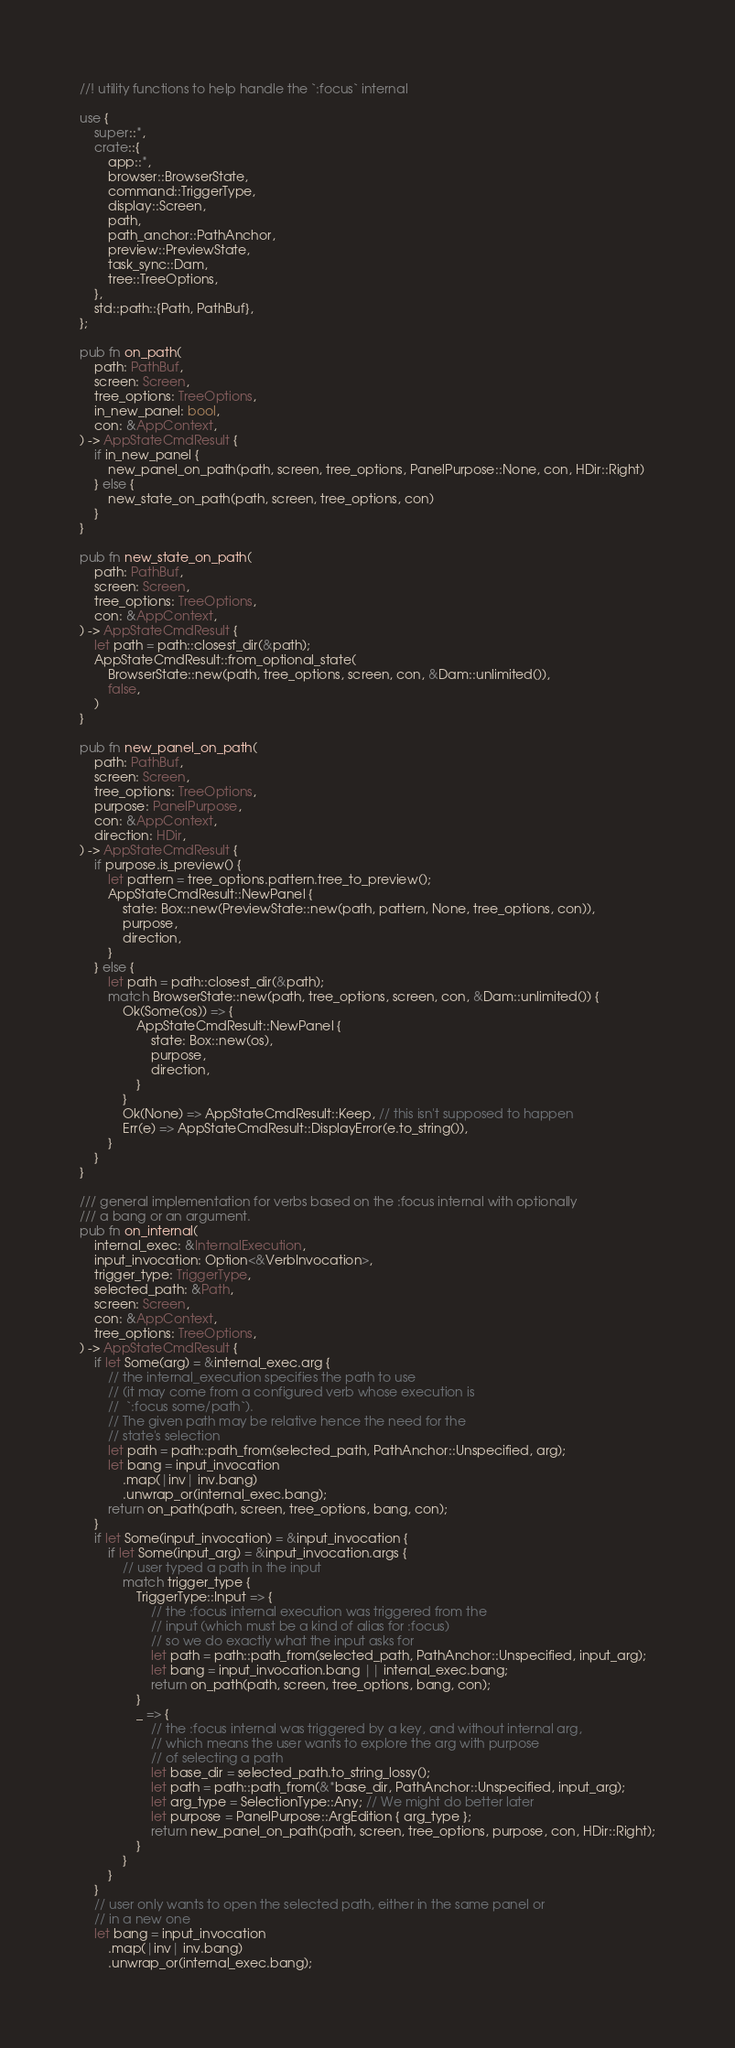Convert code to text. <code><loc_0><loc_0><loc_500><loc_500><_Rust_>//! utility functions to help handle the `:focus` internal

use {
    super::*,
    crate::{
        app::*,
        browser::BrowserState,
        command::TriggerType,
        display::Screen,
        path,
        path_anchor::PathAnchor,
        preview::PreviewState,
        task_sync::Dam,
        tree::TreeOptions,
    },
    std::path::{Path, PathBuf},
};

pub fn on_path(
    path: PathBuf,
    screen: Screen,
    tree_options: TreeOptions,
    in_new_panel: bool,
    con: &AppContext,
) -> AppStateCmdResult {
    if in_new_panel {
        new_panel_on_path(path, screen, tree_options, PanelPurpose::None, con, HDir::Right)
    } else {
        new_state_on_path(path, screen, tree_options, con)
    }
}

pub fn new_state_on_path(
    path: PathBuf,
    screen: Screen,
    tree_options: TreeOptions,
    con: &AppContext,
) -> AppStateCmdResult {
    let path = path::closest_dir(&path);
    AppStateCmdResult::from_optional_state(
        BrowserState::new(path, tree_options, screen, con, &Dam::unlimited()),
        false,
    )
}

pub fn new_panel_on_path(
    path: PathBuf,
    screen: Screen,
    tree_options: TreeOptions,
    purpose: PanelPurpose,
    con: &AppContext,
    direction: HDir,
) -> AppStateCmdResult {
    if purpose.is_preview() {
        let pattern = tree_options.pattern.tree_to_preview();
        AppStateCmdResult::NewPanel {
            state: Box::new(PreviewState::new(path, pattern, None, tree_options, con)),
            purpose,
            direction,
        }
    } else {
        let path = path::closest_dir(&path);
        match BrowserState::new(path, tree_options, screen, con, &Dam::unlimited()) {
            Ok(Some(os)) => {
                AppStateCmdResult::NewPanel {
                    state: Box::new(os),
                    purpose,
                    direction,
                }
            }
            Ok(None) => AppStateCmdResult::Keep, // this isn't supposed to happen
            Err(e) => AppStateCmdResult::DisplayError(e.to_string()),
        }
    }
}

/// general implementation for verbs based on the :focus internal with optionally
/// a bang or an argument.
pub fn on_internal(
    internal_exec: &InternalExecution,
    input_invocation: Option<&VerbInvocation>,
    trigger_type: TriggerType,
    selected_path: &Path,
    screen: Screen,
    con: &AppContext,
    tree_options: TreeOptions,
) -> AppStateCmdResult {
    if let Some(arg) = &internal_exec.arg {
        // the internal_execution specifies the path to use
        // (it may come from a configured verb whose execution is
        //  `:focus some/path`).
        // The given path may be relative hence the need for the
        // state's selection
        let path = path::path_from(selected_path, PathAnchor::Unspecified, arg);
        let bang = input_invocation
            .map(|inv| inv.bang)
            .unwrap_or(internal_exec.bang);
        return on_path(path, screen, tree_options, bang, con);
    }
    if let Some(input_invocation) = &input_invocation {
        if let Some(input_arg) = &input_invocation.args {
            // user typed a path in the input
            match trigger_type {
                TriggerType::Input => {
                    // the :focus internal execution was triggered from the
                    // input (which must be a kind of alias for :focus)
                    // so we do exactly what the input asks for
                    let path = path::path_from(selected_path, PathAnchor::Unspecified, input_arg);
                    let bang = input_invocation.bang || internal_exec.bang;
                    return on_path(path, screen, tree_options, bang, con);
                }
                _ => {
                    // the :focus internal was triggered by a key, and without internal arg,
                    // which means the user wants to explore the arg with purpose
                    // of selecting a path
                    let base_dir = selected_path.to_string_lossy();
                    let path = path::path_from(&*base_dir, PathAnchor::Unspecified, input_arg);
                    let arg_type = SelectionType::Any; // We might do better later
                    let purpose = PanelPurpose::ArgEdition { arg_type };
                    return new_panel_on_path(path, screen, tree_options, purpose, con, HDir::Right);
                }
            }
        }
    }
    // user only wants to open the selected path, either in the same panel or
    // in a new one
    let bang = input_invocation
        .map(|inv| inv.bang)
        .unwrap_or(internal_exec.bang);</code> 